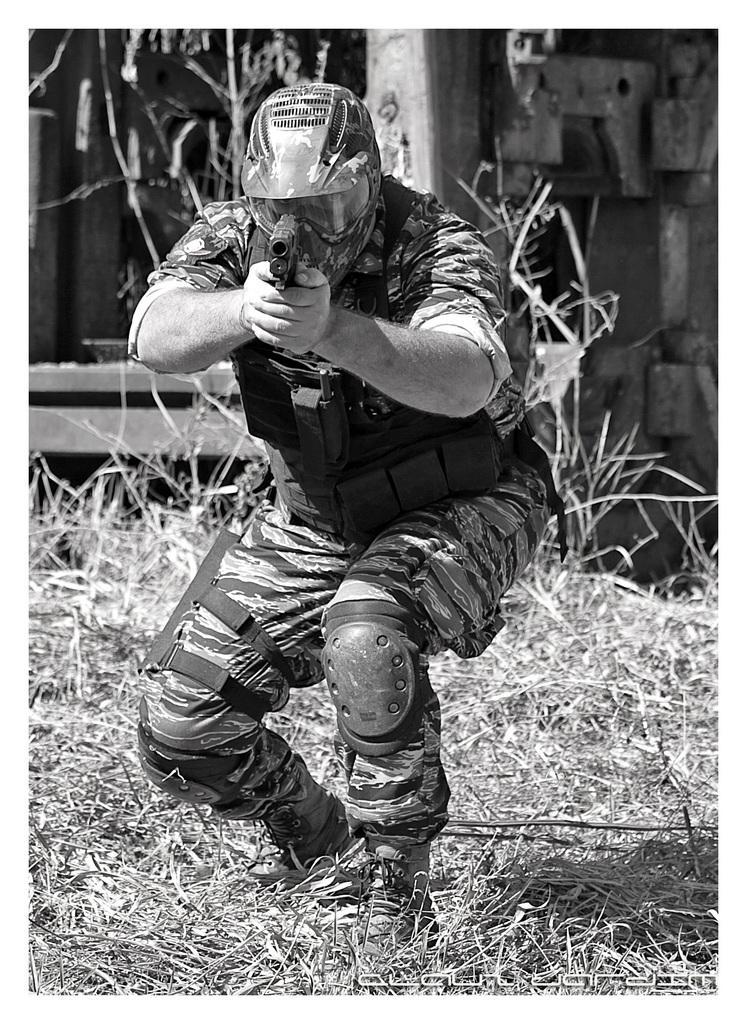In one or two sentences, can you explain what this image depicts? In this black and white picture there is a person in squat position. He is wearing a jacket, knee pads and a helmet. He is holding a gun in his hand. There is grass on the ground. Behind him there is a wall. 